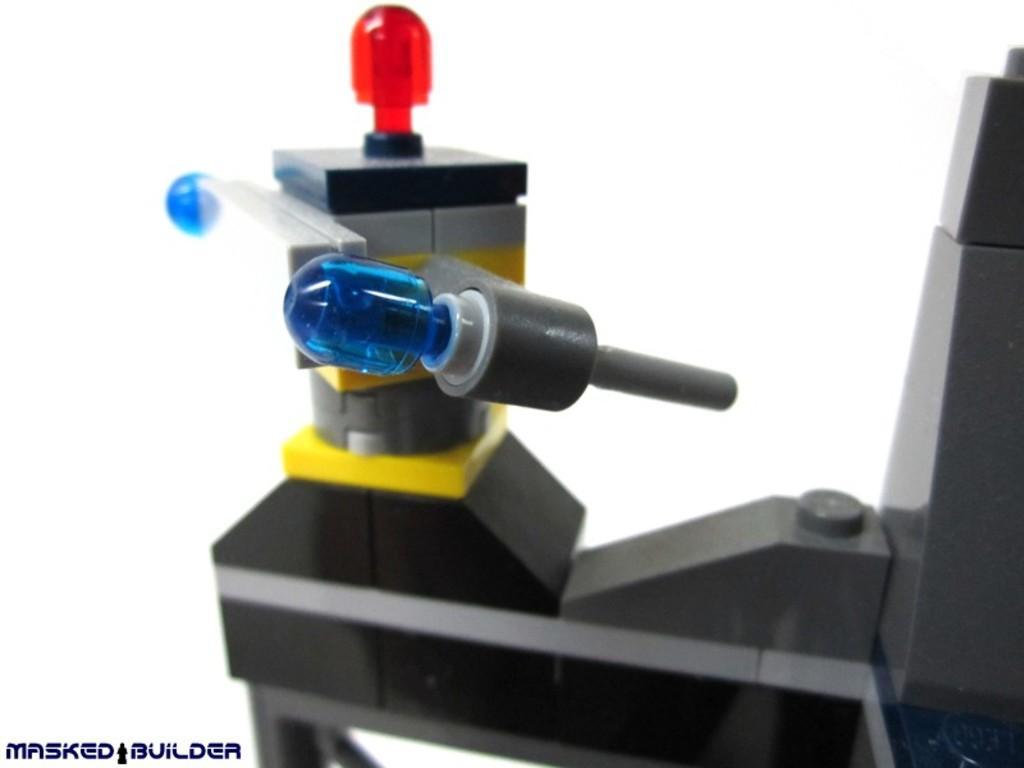Please provide a concise description of this image. In this image there is a machine tool having few LED lights. Background is in white color. Left bottom there is some text. 